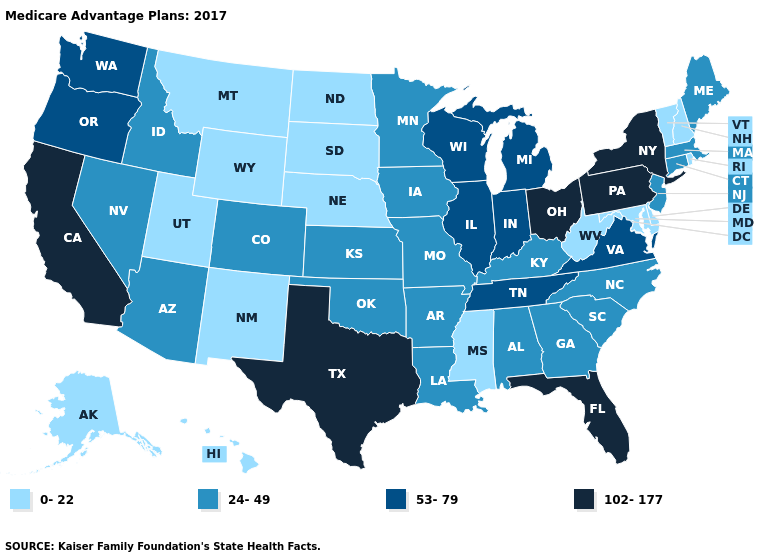Among the states that border Kansas , does Colorado have the highest value?
Give a very brief answer. Yes. What is the value of Mississippi?
Answer briefly. 0-22. Name the states that have a value in the range 0-22?
Concise answer only. Alaska, Delaware, Hawaii, Maryland, Mississippi, Montana, North Dakota, Nebraska, New Hampshire, New Mexico, Rhode Island, South Dakota, Utah, Vermont, West Virginia, Wyoming. Does Florida have the highest value in the South?
Write a very short answer. Yes. Name the states that have a value in the range 0-22?
Short answer required. Alaska, Delaware, Hawaii, Maryland, Mississippi, Montana, North Dakota, Nebraska, New Hampshire, New Mexico, Rhode Island, South Dakota, Utah, Vermont, West Virginia, Wyoming. Does the map have missing data?
Quick response, please. No. What is the value of Wisconsin?
Write a very short answer. 53-79. Which states have the lowest value in the MidWest?
Give a very brief answer. North Dakota, Nebraska, South Dakota. What is the value of Texas?
Give a very brief answer. 102-177. What is the value of Maryland?
Give a very brief answer. 0-22. Does the map have missing data?
Give a very brief answer. No. What is the value of Arizona?
Give a very brief answer. 24-49. Name the states that have a value in the range 102-177?
Concise answer only. California, Florida, New York, Ohio, Pennsylvania, Texas. What is the lowest value in the South?
Quick response, please. 0-22. What is the lowest value in the West?
Concise answer only. 0-22. 